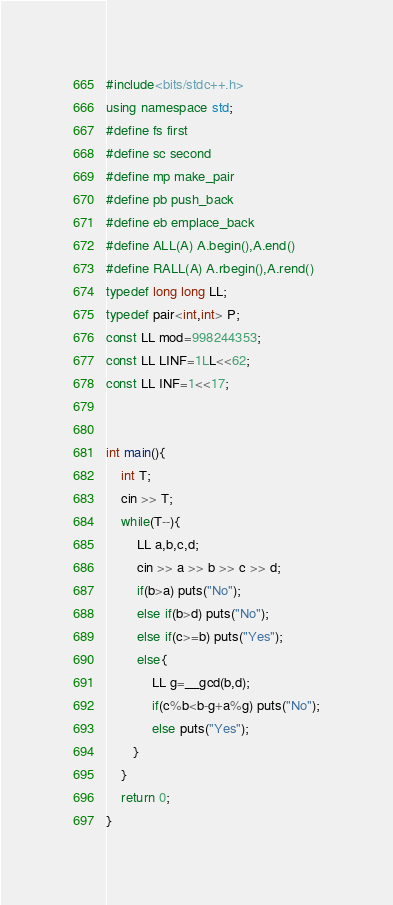<code> <loc_0><loc_0><loc_500><loc_500><_C++_>#include<bits/stdc++.h>
using namespace std;
#define fs first
#define sc second
#define mp make_pair
#define pb push_back
#define eb emplace_back
#define ALL(A) A.begin(),A.end()
#define RALL(A) A.rbegin(),A.rend()
typedef long long LL;
typedef pair<int,int> P;
const LL mod=998244353;
const LL LINF=1LL<<62;
const LL INF=1<<17;


int main(){
    int T;
    cin >> T;
    while(T--){
        LL a,b,c,d;
        cin >> a >> b >> c >> d;
        if(b>a) puts("No");
        else if(b>d) puts("No");
        else if(c>=b) puts("Yes");
        else{
            LL g=__gcd(b,d);
            if(c%b<b-g+a%g) puts("No");
            else puts("Yes");
       }
    }
    return 0;
}
</code> 